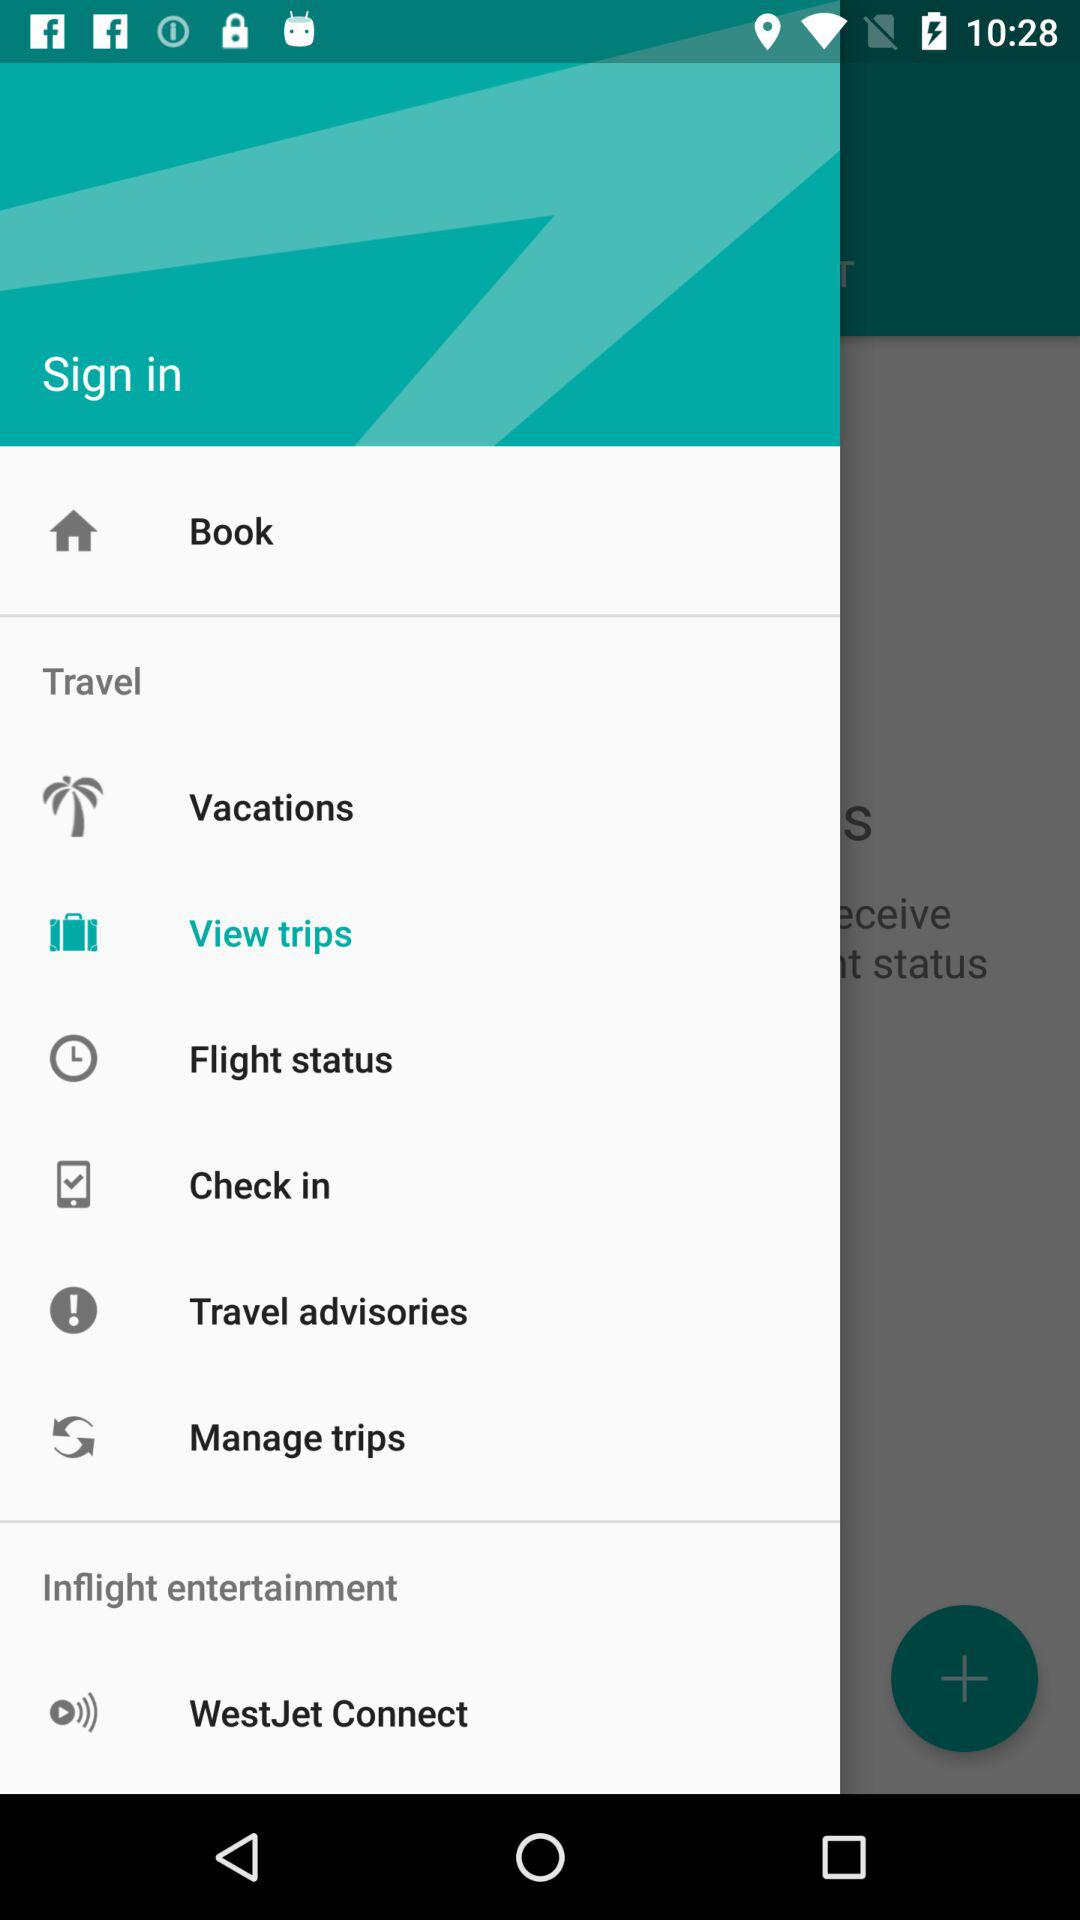What is the selected item in the menu? The selected item in the menu is "View trips". 